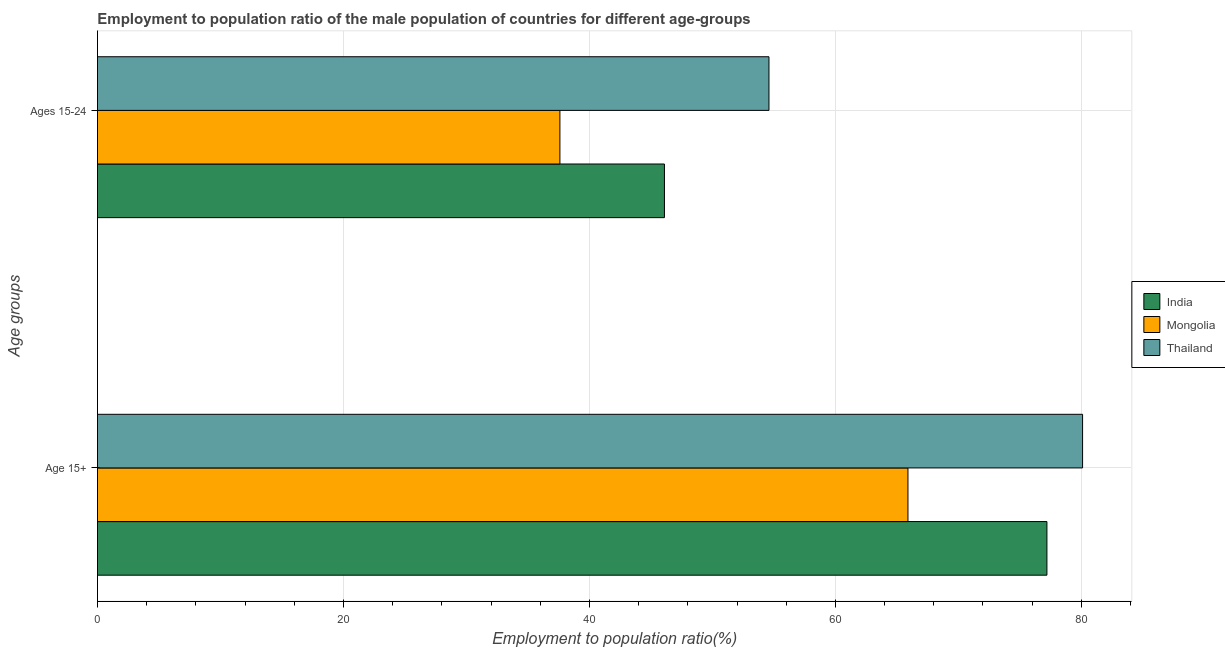How many different coloured bars are there?
Provide a short and direct response. 3. How many groups of bars are there?
Keep it short and to the point. 2. Are the number of bars per tick equal to the number of legend labels?
Your response must be concise. Yes. Are the number of bars on each tick of the Y-axis equal?
Ensure brevity in your answer.  Yes. How many bars are there on the 1st tick from the top?
Keep it short and to the point. 3. How many bars are there on the 2nd tick from the bottom?
Your response must be concise. 3. What is the label of the 1st group of bars from the top?
Your response must be concise. Ages 15-24. What is the employment to population ratio(age 15-24) in Thailand?
Ensure brevity in your answer.  54.6. Across all countries, what is the maximum employment to population ratio(age 15-24)?
Offer a terse response. 54.6. Across all countries, what is the minimum employment to population ratio(age 15+)?
Provide a succinct answer. 65.9. In which country was the employment to population ratio(age 15+) maximum?
Make the answer very short. Thailand. In which country was the employment to population ratio(age 15-24) minimum?
Provide a short and direct response. Mongolia. What is the total employment to population ratio(age 15-24) in the graph?
Offer a very short reply. 138.3. What is the difference between the employment to population ratio(age 15+) in India and that in Thailand?
Provide a succinct answer. -2.9. What is the difference between the employment to population ratio(age 15-24) in Thailand and the employment to population ratio(age 15+) in Mongolia?
Your response must be concise. -11.3. What is the average employment to population ratio(age 15+) per country?
Make the answer very short. 74.4. What is the difference between the employment to population ratio(age 15+) and employment to population ratio(age 15-24) in Mongolia?
Your response must be concise. 28.3. What is the ratio of the employment to population ratio(age 15+) in India to that in Mongolia?
Give a very brief answer. 1.17. In how many countries, is the employment to population ratio(age 15+) greater than the average employment to population ratio(age 15+) taken over all countries?
Ensure brevity in your answer.  2. What does the 3rd bar from the top in Ages 15-24 represents?
Offer a very short reply. India. How many bars are there?
Provide a short and direct response. 6. Are all the bars in the graph horizontal?
Your answer should be compact. Yes. What is the difference between two consecutive major ticks on the X-axis?
Keep it short and to the point. 20. Are the values on the major ticks of X-axis written in scientific E-notation?
Keep it short and to the point. No. How are the legend labels stacked?
Offer a terse response. Vertical. What is the title of the graph?
Ensure brevity in your answer.  Employment to population ratio of the male population of countries for different age-groups. Does "Latvia" appear as one of the legend labels in the graph?
Offer a very short reply. No. What is the label or title of the X-axis?
Give a very brief answer. Employment to population ratio(%). What is the label or title of the Y-axis?
Offer a very short reply. Age groups. What is the Employment to population ratio(%) in India in Age 15+?
Provide a short and direct response. 77.2. What is the Employment to population ratio(%) of Mongolia in Age 15+?
Ensure brevity in your answer.  65.9. What is the Employment to population ratio(%) of Thailand in Age 15+?
Your answer should be compact. 80.1. What is the Employment to population ratio(%) of India in Ages 15-24?
Provide a short and direct response. 46.1. What is the Employment to population ratio(%) of Mongolia in Ages 15-24?
Offer a terse response. 37.6. What is the Employment to population ratio(%) of Thailand in Ages 15-24?
Give a very brief answer. 54.6. Across all Age groups, what is the maximum Employment to population ratio(%) in India?
Your response must be concise. 77.2. Across all Age groups, what is the maximum Employment to population ratio(%) of Mongolia?
Your response must be concise. 65.9. Across all Age groups, what is the maximum Employment to population ratio(%) of Thailand?
Ensure brevity in your answer.  80.1. Across all Age groups, what is the minimum Employment to population ratio(%) of India?
Provide a short and direct response. 46.1. Across all Age groups, what is the minimum Employment to population ratio(%) of Mongolia?
Keep it short and to the point. 37.6. Across all Age groups, what is the minimum Employment to population ratio(%) in Thailand?
Keep it short and to the point. 54.6. What is the total Employment to population ratio(%) of India in the graph?
Provide a short and direct response. 123.3. What is the total Employment to population ratio(%) of Mongolia in the graph?
Offer a very short reply. 103.5. What is the total Employment to population ratio(%) of Thailand in the graph?
Offer a very short reply. 134.7. What is the difference between the Employment to population ratio(%) of India in Age 15+ and that in Ages 15-24?
Keep it short and to the point. 31.1. What is the difference between the Employment to population ratio(%) of Mongolia in Age 15+ and that in Ages 15-24?
Ensure brevity in your answer.  28.3. What is the difference between the Employment to population ratio(%) in India in Age 15+ and the Employment to population ratio(%) in Mongolia in Ages 15-24?
Ensure brevity in your answer.  39.6. What is the difference between the Employment to population ratio(%) of India in Age 15+ and the Employment to population ratio(%) of Thailand in Ages 15-24?
Provide a succinct answer. 22.6. What is the average Employment to population ratio(%) of India per Age groups?
Make the answer very short. 61.65. What is the average Employment to population ratio(%) of Mongolia per Age groups?
Make the answer very short. 51.75. What is the average Employment to population ratio(%) in Thailand per Age groups?
Offer a very short reply. 67.35. What is the difference between the Employment to population ratio(%) of India and Employment to population ratio(%) of Thailand in Age 15+?
Offer a terse response. -2.9. What is the difference between the Employment to population ratio(%) in Mongolia and Employment to population ratio(%) in Thailand in Age 15+?
Your answer should be very brief. -14.2. What is the difference between the Employment to population ratio(%) of Mongolia and Employment to population ratio(%) of Thailand in Ages 15-24?
Your answer should be very brief. -17. What is the ratio of the Employment to population ratio(%) in India in Age 15+ to that in Ages 15-24?
Provide a succinct answer. 1.67. What is the ratio of the Employment to population ratio(%) in Mongolia in Age 15+ to that in Ages 15-24?
Provide a short and direct response. 1.75. What is the ratio of the Employment to population ratio(%) of Thailand in Age 15+ to that in Ages 15-24?
Your response must be concise. 1.47. What is the difference between the highest and the second highest Employment to population ratio(%) in India?
Ensure brevity in your answer.  31.1. What is the difference between the highest and the second highest Employment to population ratio(%) of Mongolia?
Provide a succinct answer. 28.3. What is the difference between the highest and the second highest Employment to population ratio(%) in Thailand?
Ensure brevity in your answer.  25.5. What is the difference between the highest and the lowest Employment to population ratio(%) of India?
Provide a short and direct response. 31.1. What is the difference between the highest and the lowest Employment to population ratio(%) in Mongolia?
Your response must be concise. 28.3. 